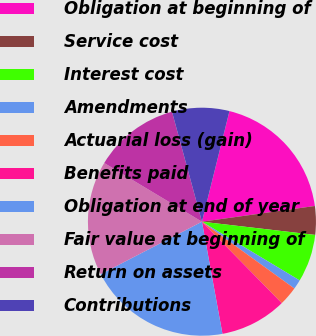Convert chart. <chart><loc_0><loc_0><loc_500><loc_500><pie_chart><fcel>Obligation at beginning of<fcel>Service cost<fcel>Interest cost<fcel>Amendments<fcel>Actuarial loss (gain)<fcel>Benefits paid<fcel>Obligation at end of year<fcel>Fair value at beginning of<fcel>Return on assets<fcel>Contributions<nl><fcel>18.92%<fcel>4.05%<fcel>6.76%<fcel>1.35%<fcel>2.7%<fcel>9.46%<fcel>20.27%<fcel>16.22%<fcel>12.16%<fcel>8.11%<nl></chart> 